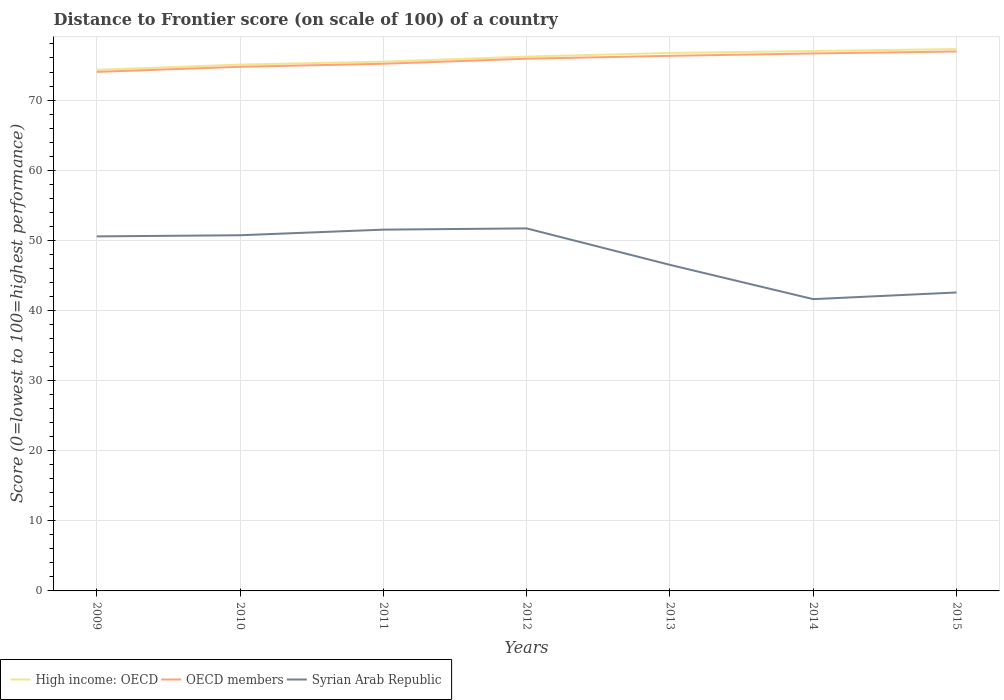Is the number of lines equal to the number of legend labels?
Provide a short and direct response. Yes. Across all years, what is the maximum distance to frontier score of in OECD members?
Make the answer very short. 74.02. What is the total distance to frontier score of in High income: OECD in the graph?
Provide a succinct answer. -1.66. What is the difference between the highest and the second highest distance to frontier score of in Syrian Arab Republic?
Provide a succinct answer. 10.09. What is the difference between the highest and the lowest distance to frontier score of in OECD members?
Your answer should be very brief. 4. What is the difference between two consecutive major ticks on the Y-axis?
Ensure brevity in your answer.  10. Are the values on the major ticks of Y-axis written in scientific E-notation?
Make the answer very short. No. Does the graph contain grids?
Ensure brevity in your answer.  Yes. Where does the legend appear in the graph?
Provide a succinct answer. Bottom left. How many legend labels are there?
Offer a very short reply. 3. What is the title of the graph?
Provide a short and direct response. Distance to Frontier score (on scale of 100) of a country. What is the label or title of the X-axis?
Provide a short and direct response. Years. What is the label or title of the Y-axis?
Provide a succinct answer. Score (0=lowest to 100=highest performance). What is the Score (0=lowest to 100=highest performance) in High income: OECD in 2009?
Keep it short and to the point. 74.31. What is the Score (0=lowest to 100=highest performance) of OECD members in 2009?
Your response must be concise. 74.02. What is the Score (0=lowest to 100=highest performance) in Syrian Arab Republic in 2009?
Offer a terse response. 50.56. What is the Score (0=lowest to 100=highest performance) in High income: OECD in 2010?
Give a very brief answer. 75.06. What is the Score (0=lowest to 100=highest performance) in OECD members in 2010?
Offer a terse response. 74.74. What is the Score (0=lowest to 100=highest performance) of Syrian Arab Republic in 2010?
Keep it short and to the point. 50.72. What is the Score (0=lowest to 100=highest performance) in High income: OECD in 2011?
Keep it short and to the point. 75.48. What is the Score (0=lowest to 100=highest performance) of OECD members in 2011?
Ensure brevity in your answer.  75.18. What is the Score (0=lowest to 100=highest performance) of Syrian Arab Republic in 2011?
Provide a succinct answer. 51.52. What is the Score (0=lowest to 100=highest performance) in High income: OECD in 2012?
Ensure brevity in your answer.  76.2. What is the Score (0=lowest to 100=highest performance) of OECD members in 2012?
Offer a very short reply. 75.9. What is the Score (0=lowest to 100=highest performance) of Syrian Arab Republic in 2012?
Ensure brevity in your answer.  51.7. What is the Score (0=lowest to 100=highest performance) in High income: OECD in 2013?
Ensure brevity in your answer.  76.72. What is the Score (0=lowest to 100=highest performance) in OECD members in 2013?
Ensure brevity in your answer.  76.31. What is the Score (0=lowest to 100=highest performance) in Syrian Arab Republic in 2013?
Your answer should be very brief. 46.5. What is the Score (0=lowest to 100=highest performance) of High income: OECD in 2014?
Your answer should be compact. 77. What is the Score (0=lowest to 100=highest performance) in OECD members in 2014?
Offer a very short reply. 76.65. What is the Score (0=lowest to 100=highest performance) of Syrian Arab Republic in 2014?
Provide a short and direct response. 41.61. What is the Score (0=lowest to 100=highest performance) of High income: OECD in 2015?
Offer a terse response. 77.27. What is the Score (0=lowest to 100=highest performance) in OECD members in 2015?
Give a very brief answer. 76.93. What is the Score (0=lowest to 100=highest performance) in Syrian Arab Republic in 2015?
Make the answer very short. 42.56. Across all years, what is the maximum Score (0=lowest to 100=highest performance) in High income: OECD?
Offer a very short reply. 77.27. Across all years, what is the maximum Score (0=lowest to 100=highest performance) of OECD members?
Offer a terse response. 76.93. Across all years, what is the maximum Score (0=lowest to 100=highest performance) of Syrian Arab Republic?
Your response must be concise. 51.7. Across all years, what is the minimum Score (0=lowest to 100=highest performance) of High income: OECD?
Offer a terse response. 74.31. Across all years, what is the minimum Score (0=lowest to 100=highest performance) in OECD members?
Your answer should be very brief. 74.02. Across all years, what is the minimum Score (0=lowest to 100=highest performance) of Syrian Arab Republic?
Your answer should be very brief. 41.61. What is the total Score (0=lowest to 100=highest performance) of High income: OECD in the graph?
Provide a succinct answer. 532.03. What is the total Score (0=lowest to 100=highest performance) in OECD members in the graph?
Offer a very short reply. 529.71. What is the total Score (0=lowest to 100=highest performance) in Syrian Arab Republic in the graph?
Your answer should be compact. 335.17. What is the difference between the Score (0=lowest to 100=highest performance) in High income: OECD in 2009 and that in 2010?
Keep it short and to the point. -0.75. What is the difference between the Score (0=lowest to 100=highest performance) in OECD members in 2009 and that in 2010?
Give a very brief answer. -0.73. What is the difference between the Score (0=lowest to 100=highest performance) in Syrian Arab Republic in 2009 and that in 2010?
Make the answer very short. -0.16. What is the difference between the Score (0=lowest to 100=highest performance) in High income: OECD in 2009 and that in 2011?
Your response must be concise. -1.17. What is the difference between the Score (0=lowest to 100=highest performance) in OECD members in 2009 and that in 2011?
Your answer should be compact. -1.16. What is the difference between the Score (0=lowest to 100=highest performance) of Syrian Arab Republic in 2009 and that in 2011?
Offer a terse response. -0.96. What is the difference between the Score (0=lowest to 100=highest performance) in High income: OECD in 2009 and that in 2012?
Ensure brevity in your answer.  -1.89. What is the difference between the Score (0=lowest to 100=highest performance) of OECD members in 2009 and that in 2012?
Keep it short and to the point. -1.88. What is the difference between the Score (0=lowest to 100=highest performance) in Syrian Arab Republic in 2009 and that in 2012?
Provide a succinct answer. -1.14. What is the difference between the Score (0=lowest to 100=highest performance) of High income: OECD in 2009 and that in 2013?
Make the answer very short. -2.41. What is the difference between the Score (0=lowest to 100=highest performance) in OECD members in 2009 and that in 2013?
Your answer should be compact. -2.29. What is the difference between the Score (0=lowest to 100=highest performance) in Syrian Arab Republic in 2009 and that in 2013?
Your answer should be compact. 4.06. What is the difference between the Score (0=lowest to 100=highest performance) of High income: OECD in 2009 and that in 2014?
Your answer should be very brief. -2.69. What is the difference between the Score (0=lowest to 100=highest performance) in OECD members in 2009 and that in 2014?
Your response must be concise. -2.63. What is the difference between the Score (0=lowest to 100=highest performance) in Syrian Arab Republic in 2009 and that in 2014?
Your answer should be compact. 8.95. What is the difference between the Score (0=lowest to 100=highest performance) of High income: OECD in 2009 and that in 2015?
Provide a short and direct response. -2.96. What is the difference between the Score (0=lowest to 100=highest performance) of OECD members in 2009 and that in 2015?
Offer a very short reply. -2.91. What is the difference between the Score (0=lowest to 100=highest performance) of Syrian Arab Republic in 2009 and that in 2015?
Ensure brevity in your answer.  8. What is the difference between the Score (0=lowest to 100=highest performance) of High income: OECD in 2010 and that in 2011?
Provide a succinct answer. -0.42. What is the difference between the Score (0=lowest to 100=highest performance) of OECD members in 2010 and that in 2011?
Your response must be concise. -0.43. What is the difference between the Score (0=lowest to 100=highest performance) in High income: OECD in 2010 and that in 2012?
Keep it short and to the point. -1.14. What is the difference between the Score (0=lowest to 100=highest performance) of OECD members in 2010 and that in 2012?
Provide a short and direct response. -1.15. What is the difference between the Score (0=lowest to 100=highest performance) of Syrian Arab Republic in 2010 and that in 2012?
Your answer should be compact. -0.98. What is the difference between the Score (0=lowest to 100=highest performance) of High income: OECD in 2010 and that in 2013?
Ensure brevity in your answer.  -1.66. What is the difference between the Score (0=lowest to 100=highest performance) in OECD members in 2010 and that in 2013?
Make the answer very short. -1.56. What is the difference between the Score (0=lowest to 100=highest performance) of Syrian Arab Republic in 2010 and that in 2013?
Ensure brevity in your answer.  4.22. What is the difference between the Score (0=lowest to 100=highest performance) of High income: OECD in 2010 and that in 2014?
Give a very brief answer. -1.94. What is the difference between the Score (0=lowest to 100=highest performance) of OECD members in 2010 and that in 2014?
Your answer should be very brief. -1.9. What is the difference between the Score (0=lowest to 100=highest performance) of Syrian Arab Republic in 2010 and that in 2014?
Your answer should be very brief. 9.11. What is the difference between the Score (0=lowest to 100=highest performance) in High income: OECD in 2010 and that in 2015?
Offer a very short reply. -2.21. What is the difference between the Score (0=lowest to 100=highest performance) of OECD members in 2010 and that in 2015?
Ensure brevity in your answer.  -2.18. What is the difference between the Score (0=lowest to 100=highest performance) of Syrian Arab Republic in 2010 and that in 2015?
Make the answer very short. 8.16. What is the difference between the Score (0=lowest to 100=highest performance) of High income: OECD in 2011 and that in 2012?
Your response must be concise. -0.72. What is the difference between the Score (0=lowest to 100=highest performance) in OECD members in 2011 and that in 2012?
Offer a terse response. -0.72. What is the difference between the Score (0=lowest to 100=highest performance) in Syrian Arab Republic in 2011 and that in 2012?
Make the answer very short. -0.18. What is the difference between the Score (0=lowest to 100=highest performance) of High income: OECD in 2011 and that in 2013?
Provide a short and direct response. -1.24. What is the difference between the Score (0=lowest to 100=highest performance) in OECD members in 2011 and that in 2013?
Keep it short and to the point. -1.13. What is the difference between the Score (0=lowest to 100=highest performance) in Syrian Arab Republic in 2011 and that in 2013?
Your response must be concise. 5.02. What is the difference between the Score (0=lowest to 100=highest performance) in High income: OECD in 2011 and that in 2014?
Give a very brief answer. -1.52. What is the difference between the Score (0=lowest to 100=highest performance) in OECD members in 2011 and that in 2014?
Keep it short and to the point. -1.47. What is the difference between the Score (0=lowest to 100=highest performance) of Syrian Arab Republic in 2011 and that in 2014?
Offer a very short reply. 9.91. What is the difference between the Score (0=lowest to 100=highest performance) of High income: OECD in 2011 and that in 2015?
Your answer should be very brief. -1.79. What is the difference between the Score (0=lowest to 100=highest performance) of OECD members in 2011 and that in 2015?
Offer a terse response. -1.75. What is the difference between the Score (0=lowest to 100=highest performance) in Syrian Arab Republic in 2011 and that in 2015?
Provide a short and direct response. 8.96. What is the difference between the Score (0=lowest to 100=highest performance) of High income: OECD in 2012 and that in 2013?
Provide a short and direct response. -0.52. What is the difference between the Score (0=lowest to 100=highest performance) in OECD members in 2012 and that in 2013?
Keep it short and to the point. -0.41. What is the difference between the Score (0=lowest to 100=highest performance) of Syrian Arab Republic in 2012 and that in 2013?
Offer a very short reply. 5.2. What is the difference between the Score (0=lowest to 100=highest performance) of High income: OECD in 2012 and that in 2014?
Your response must be concise. -0.8. What is the difference between the Score (0=lowest to 100=highest performance) in OECD members in 2012 and that in 2014?
Offer a very short reply. -0.75. What is the difference between the Score (0=lowest to 100=highest performance) of Syrian Arab Republic in 2012 and that in 2014?
Ensure brevity in your answer.  10.09. What is the difference between the Score (0=lowest to 100=highest performance) in High income: OECD in 2012 and that in 2015?
Your response must be concise. -1.07. What is the difference between the Score (0=lowest to 100=highest performance) of OECD members in 2012 and that in 2015?
Provide a succinct answer. -1.03. What is the difference between the Score (0=lowest to 100=highest performance) of Syrian Arab Republic in 2012 and that in 2015?
Provide a short and direct response. 9.14. What is the difference between the Score (0=lowest to 100=highest performance) of High income: OECD in 2013 and that in 2014?
Your answer should be compact. -0.28. What is the difference between the Score (0=lowest to 100=highest performance) in OECD members in 2013 and that in 2014?
Ensure brevity in your answer.  -0.34. What is the difference between the Score (0=lowest to 100=highest performance) of Syrian Arab Republic in 2013 and that in 2014?
Provide a succinct answer. 4.89. What is the difference between the Score (0=lowest to 100=highest performance) in High income: OECD in 2013 and that in 2015?
Offer a very short reply. -0.55. What is the difference between the Score (0=lowest to 100=highest performance) in OECD members in 2013 and that in 2015?
Give a very brief answer. -0.62. What is the difference between the Score (0=lowest to 100=highest performance) of Syrian Arab Republic in 2013 and that in 2015?
Your answer should be very brief. 3.94. What is the difference between the Score (0=lowest to 100=highest performance) of High income: OECD in 2014 and that in 2015?
Offer a very short reply. -0.27. What is the difference between the Score (0=lowest to 100=highest performance) in OECD members in 2014 and that in 2015?
Give a very brief answer. -0.28. What is the difference between the Score (0=lowest to 100=highest performance) of Syrian Arab Republic in 2014 and that in 2015?
Keep it short and to the point. -0.95. What is the difference between the Score (0=lowest to 100=highest performance) in High income: OECD in 2009 and the Score (0=lowest to 100=highest performance) in OECD members in 2010?
Your response must be concise. -0.44. What is the difference between the Score (0=lowest to 100=highest performance) in High income: OECD in 2009 and the Score (0=lowest to 100=highest performance) in Syrian Arab Republic in 2010?
Provide a succinct answer. 23.59. What is the difference between the Score (0=lowest to 100=highest performance) in OECD members in 2009 and the Score (0=lowest to 100=highest performance) in Syrian Arab Republic in 2010?
Give a very brief answer. 23.3. What is the difference between the Score (0=lowest to 100=highest performance) of High income: OECD in 2009 and the Score (0=lowest to 100=highest performance) of OECD members in 2011?
Your answer should be compact. -0.87. What is the difference between the Score (0=lowest to 100=highest performance) in High income: OECD in 2009 and the Score (0=lowest to 100=highest performance) in Syrian Arab Republic in 2011?
Ensure brevity in your answer.  22.79. What is the difference between the Score (0=lowest to 100=highest performance) of OECD members in 2009 and the Score (0=lowest to 100=highest performance) of Syrian Arab Republic in 2011?
Offer a very short reply. 22.5. What is the difference between the Score (0=lowest to 100=highest performance) of High income: OECD in 2009 and the Score (0=lowest to 100=highest performance) of OECD members in 2012?
Your answer should be compact. -1.59. What is the difference between the Score (0=lowest to 100=highest performance) of High income: OECD in 2009 and the Score (0=lowest to 100=highest performance) of Syrian Arab Republic in 2012?
Your answer should be very brief. 22.61. What is the difference between the Score (0=lowest to 100=highest performance) of OECD members in 2009 and the Score (0=lowest to 100=highest performance) of Syrian Arab Republic in 2012?
Make the answer very short. 22.32. What is the difference between the Score (0=lowest to 100=highest performance) of High income: OECD in 2009 and the Score (0=lowest to 100=highest performance) of OECD members in 2013?
Ensure brevity in your answer.  -2. What is the difference between the Score (0=lowest to 100=highest performance) of High income: OECD in 2009 and the Score (0=lowest to 100=highest performance) of Syrian Arab Republic in 2013?
Offer a terse response. 27.81. What is the difference between the Score (0=lowest to 100=highest performance) of OECD members in 2009 and the Score (0=lowest to 100=highest performance) of Syrian Arab Republic in 2013?
Give a very brief answer. 27.52. What is the difference between the Score (0=lowest to 100=highest performance) of High income: OECD in 2009 and the Score (0=lowest to 100=highest performance) of OECD members in 2014?
Provide a short and direct response. -2.34. What is the difference between the Score (0=lowest to 100=highest performance) in High income: OECD in 2009 and the Score (0=lowest to 100=highest performance) in Syrian Arab Republic in 2014?
Your response must be concise. 32.7. What is the difference between the Score (0=lowest to 100=highest performance) in OECD members in 2009 and the Score (0=lowest to 100=highest performance) in Syrian Arab Republic in 2014?
Offer a very short reply. 32.41. What is the difference between the Score (0=lowest to 100=highest performance) of High income: OECD in 2009 and the Score (0=lowest to 100=highest performance) of OECD members in 2015?
Provide a short and direct response. -2.62. What is the difference between the Score (0=lowest to 100=highest performance) in High income: OECD in 2009 and the Score (0=lowest to 100=highest performance) in Syrian Arab Republic in 2015?
Your answer should be very brief. 31.75. What is the difference between the Score (0=lowest to 100=highest performance) of OECD members in 2009 and the Score (0=lowest to 100=highest performance) of Syrian Arab Republic in 2015?
Your response must be concise. 31.46. What is the difference between the Score (0=lowest to 100=highest performance) in High income: OECD in 2010 and the Score (0=lowest to 100=highest performance) in OECD members in 2011?
Make the answer very short. -0.12. What is the difference between the Score (0=lowest to 100=highest performance) in High income: OECD in 2010 and the Score (0=lowest to 100=highest performance) in Syrian Arab Republic in 2011?
Provide a short and direct response. 23.54. What is the difference between the Score (0=lowest to 100=highest performance) in OECD members in 2010 and the Score (0=lowest to 100=highest performance) in Syrian Arab Republic in 2011?
Your answer should be very brief. 23.22. What is the difference between the Score (0=lowest to 100=highest performance) in High income: OECD in 2010 and the Score (0=lowest to 100=highest performance) in OECD members in 2012?
Offer a terse response. -0.84. What is the difference between the Score (0=lowest to 100=highest performance) of High income: OECD in 2010 and the Score (0=lowest to 100=highest performance) of Syrian Arab Republic in 2012?
Provide a succinct answer. 23.36. What is the difference between the Score (0=lowest to 100=highest performance) of OECD members in 2010 and the Score (0=lowest to 100=highest performance) of Syrian Arab Republic in 2012?
Your answer should be very brief. 23.04. What is the difference between the Score (0=lowest to 100=highest performance) in High income: OECD in 2010 and the Score (0=lowest to 100=highest performance) in OECD members in 2013?
Offer a very short reply. -1.25. What is the difference between the Score (0=lowest to 100=highest performance) in High income: OECD in 2010 and the Score (0=lowest to 100=highest performance) in Syrian Arab Republic in 2013?
Make the answer very short. 28.56. What is the difference between the Score (0=lowest to 100=highest performance) in OECD members in 2010 and the Score (0=lowest to 100=highest performance) in Syrian Arab Republic in 2013?
Ensure brevity in your answer.  28.24. What is the difference between the Score (0=lowest to 100=highest performance) in High income: OECD in 2010 and the Score (0=lowest to 100=highest performance) in OECD members in 2014?
Provide a succinct answer. -1.59. What is the difference between the Score (0=lowest to 100=highest performance) in High income: OECD in 2010 and the Score (0=lowest to 100=highest performance) in Syrian Arab Republic in 2014?
Your answer should be compact. 33.45. What is the difference between the Score (0=lowest to 100=highest performance) in OECD members in 2010 and the Score (0=lowest to 100=highest performance) in Syrian Arab Republic in 2014?
Make the answer very short. 33.13. What is the difference between the Score (0=lowest to 100=highest performance) in High income: OECD in 2010 and the Score (0=lowest to 100=highest performance) in OECD members in 2015?
Ensure brevity in your answer.  -1.87. What is the difference between the Score (0=lowest to 100=highest performance) of High income: OECD in 2010 and the Score (0=lowest to 100=highest performance) of Syrian Arab Republic in 2015?
Make the answer very short. 32.5. What is the difference between the Score (0=lowest to 100=highest performance) in OECD members in 2010 and the Score (0=lowest to 100=highest performance) in Syrian Arab Republic in 2015?
Your answer should be very brief. 32.18. What is the difference between the Score (0=lowest to 100=highest performance) in High income: OECD in 2011 and the Score (0=lowest to 100=highest performance) in OECD members in 2012?
Make the answer very short. -0.42. What is the difference between the Score (0=lowest to 100=highest performance) of High income: OECD in 2011 and the Score (0=lowest to 100=highest performance) of Syrian Arab Republic in 2012?
Your response must be concise. 23.78. What is the difference between the Score (0=lowest to 100=highest performance) in OECD members in 2011 and the Score (0=lowest to 100=highest performance) in Syrian Arab Republic in 2012?
Ensure brevity in your answer.  23.48. What is the difference between the Score (0=lowest to 100=highest performance) in High income: OECD in 2011 and the Score (0=lowest to 100=highest performance) in OECD members in 2013?
Keep it short and to the point. -0.83. What is the difference between the Score (0=lowest to 100=highest performance) of High income: OECD in 2011 and the Score (0=lowest to 100=highest performance) of Syrian Arab Republic in 2013?
Make the answer very short. 28.98. What is the difference between the Score (0=lowest to 100=highest performance) of OECD members in 2011 and the Score (0=lowest to 100=highest performance) of Syrian Arab Republic in 2013?
Give a very brief answer. 28.68. What is the difference between the Score (0=lowest to 100=highest performance) of High income: OECD in 2011 and the Score (0=lowest to 100=highest performance) of OECD members in 2014?
Provide a short and direct response. -1.17. What is the difference between the Score (0=lowest to 100=highest performance) of High income: OECD in 2011 and the Score (0=lowest to 100=highest performance) of Syrian Arab Republic in 2014?
Your answer should be compact. 33.87. What is the difference between the Score (0=lowest to 100=highest performance) in OECD members in 2011 and the Score (0=lowest to 100=highest performance) in Syrian Arab Republic in 2014?
Keep it short and to the point. 33.57. What is the difference between the Score (0=lowest to 100=highest performance) in High income: OECD in 2011 and the Score (0=lowest to 100=highest performance) in OECD members in 2015?
Provide a short and direct response. -1.45. What is the difference between the Score (0=lowest to 100=highest performance) of High income: OECD in 2011 and the Score (0=lowest to 100=highest performance) of Syrian Arab Republic in 2015?
Keep it short and to the point. 32.92. What is the difference between the Score (0=lowest to 100=highest performance) of OECD members in 2011 and the Score (0=lowest to 100=highest performance) of Syrian Arab Republic in 2015?
Keep it short and to the point. 32.62. What is the difference between the Score (0=lowest to 100=highest performance) of High income: OECD in 2012 and the Score (0=lowest to 100=highest performance) of OECD members in 2013?
Ensure brevity in your answer.  -0.11. What is the difference between the Score (0=lowest to 100=highest performance) of High income: OECD in 2012 and the Score (0=lowest to 100=highest performance) of Syrian Arab Republic in 2013?
Keep it short and to the point. 29.7. What is the difference between the Score (0=lowest to 100=highest performance) in OECD members in 2012 and the Score (0=lowest to 100=highest performance) in Syrian Arab Republic in 2013?
Your response must be concise. 29.4. What is the difference between the Score (0=lowest to 100=highest performance) in High income: OECD in 2012 and the Score (0=lowest to 100=highest performance) in OECD members in 2014?
Offer a terse response. -0.45. What is the difference between the Score (0=lowest to 100=highest performance) in High income: OECD in 2012 and the Score (0=lowest to 100=highest performance) in Syrian Arab Republic in 2014?
Make the answer very short. 34.59. What is the difference between the Score (0=lowest to 100=highest performance) of OECD members in 2012 and the Score (0=lowest to 100=highest performance) of Syrian Arab Republic in 2014?
Offer a very short reply. 34.29. What is the difference between the Score (0=lowest to 100=highest performance) of High income: OECD in 2012 and the Score (0=lowest to 100=highest performance) of OECD members in 2015?
Provide a succinct answer. -0.73. What is the difference between the Score (0=lowest to 100=highest performance) in High income: OECD in 2012 and the Score (0=lowest to 100=highest performance) in Syrian Arab Republic in 2015?
Offer a very short reply. 33.64. What is the difference between the Score (0=lowest to 100=highest performance) of OECD members in 2012 and the Score (0=lowest to 100=highest performance) of Syrian Arab Republic in 2015?
Your answer should be very brief. 33.34. What is the difference between the Score (0=lowest to 100=highest performance) in High income: OECD in 2013 and the Score (0=lowest to 100=highest performance) in OECD members in 2014?
Ensure brevity in your answer.  0.07. What is the difference between the Score (0=lowest to 100=highest performance) in High income: OECD in 2013 and the Score (0=lowest to 100=highest performance) in Syrian Arab Republic in 2014?
Offer a terse response. 35.11. What is the difference between the Score (0=lowest to 100=highest performance) of OECD members in 2013 and the Score (0=lowest to 100=highest performance) of Syrian Arab Republic in 2014?
Your answer should be compact. 34.7. What is the difference between the Score (0=lowest to 100=highest performance) of High income: OECD in 2013 and the Score (0=lowest to 100=highest performance) of OECD members in 2015?
Provide a short and direct response. -0.21. What is the difference between the Score (0=lowest to 100=highest performance) in High income: OECD in 2013 and the Score (0=lowest to 100=highest performance) in Syrian Arab Republic in 2015?
Make the answer very short. 34.16. What is the difference between the Score (0=lowest to 100=highest performance) of OECD members in 2013 and the Score (0=lowest to 100=highest performance) of Syrian Arab Republic in 2015?
Provide a short and direct response. 33.75. What is the difference between the Score (0=lowest to 100=highest performance) of High income: OECD in 2014 and the Score (0=lowest to 100=highest performance) of OECD members in 2015?
Keep it short and to the point. 0.07. What is the difference between the Score (0=lowest to 100=highest performance) in High income: OECD in 2014 and the Score (0=lowest to 100=highest performance) in Syrian Arab Republic in 2015?
Provide a succinct answer. 34.44. What is the difference between the Score (0=lowest to 100=highest performance) in OECD members in 2014 and the Score (0=lowest to 100=highest performance) in Syrian Arab Republic in 2015?
Your answer should be very brief. 34.09. What is the average Score (0=lowest to 100=highest performance) in High income: OECD per year?
Offer a terse response. 76. What is the average Score (0=lowest to 100=highest performance) in OECD members per year?
Keep it short and to the point. 75.67. What is the average Score (0=lowest to 100=highest performance) in Syrian Arab Republic per year?
Give a very brief answer. 47.88. In the year 2009, what is the difference between the Score (0=lowest to 100=highest performance) in High income: OECD and Score (0=lowest to 100=highest performance) in OECD members?
Your answer should be compact. 0.29. In the year 2009, what is the difference between the Score (0=lowest to 100=highest performance) in High income: OECD and Score (0=lowest to 100=highest performance) in Syrian Arab Republic?
Your answer should be compact. 23.75. In the year 2009, what is the difference between the Score (0=lowest to 100=highest performance) in OECD members and Score (0=lowest to 100=highest performance) in Syrian Arab Republic?
Your response must be concise. 23.46. In the year 2010, what is the difference between the Score (0=lowest to 100=highest performance) in High income: OECD and Score (0=lowest to 100=highest performance) in OECD members?
Give a very brief answer. 0.31. In the year 2010, what is the difference between the Score (0=lowest to 100=highest performance) in High income: OECD and Score (0=lowest to 100=highest performance) in Syrian Arab Republic?
Give a very brief answer. 24.34. In the year 2010, what is the difference between the Score (0=lowest to 100=highest performance) in OECD members and Score (0=lowest to 100=highest performance) in Syrian Arab Republic?
Your answer should be very brief. 24.02. In the year 2011, what is the difference between the Score (0=lowest to 100=highest performance) of High income: OECD and Score (0=lowest to 100=highest performance) of OECD members?
Ensure brevity in your answer.  0.3. In the year 2011, what is the difference between the Score (0=lowest to 100=highest performance) in High income: OECD and Score (0=lowest to 100=highest performance) in Syrian Arab Republic?
Your answer should be very brief. 23.96. In the year 2011, what is the difference between the Score (0=lowest to 100=highest performance) of OECD members and Score (0=lowest to 100=highest performance) of Syrian Arab Republic?
Provide a short and direct response. 23.66. In the year 2012, what is the difference between the Score (0=lowest to 100=highest performance) in High income: OECD and Score (0=lowest to 100=highest performance) in OECD members?
Offer a terse response. 0.3. In the year 2012, what is the difference between the Score (0=lowest to 100=highest performance) of High income: OECD and Score (0=lowest to 100=highest performance) of Syrian Arab Republic?
Keep it short and to the point. 24.5. In the year 2012, what is the difference between the Score (0=lowest to 100=highest performance) in OECD members and Score (0=lowest to 100=highest performance) in Syrian Arab Republic?
Ensure brevity in your answer.  24.2. In the year 2013, what is the difference between the Score (0=lowest to 100=highest performance) in High income: OECD and Score (0=lowest to 100=highest performance) in OECD members?
Offer a terse response. 0.41. In the year 2013, what is the difference between the Score (0=lowest to 100=highest performance) of High income: OECD and Score (0=lowest to 100=highest performance) of Syrian Arab Republic?
Provide a short and direct response. 30.22. In the year 2013, what is the difference between the Score (0=lowest to 100=highest performance) in OECD members and Score (0=lowest to 100=highest performance) in Syrian Arab Republic?
Make the answer very short. 29.81. In the year 2014, what is the difference between the Score (0=lowest to 100=highest performance) in High income: OECD and Score (0=lowest to 100=highest performance) in OECD members?
Ensure brevity in your answer.  0.35. In the year 2014, what is the difference between the Score (0=lowest to 100=highest performance) in High income: OECD and Score (0=lowest to 100=highest performance) in Syrian Arab Republic?
Offer a terse response. 35.39. In the year 2014, what is the difference between the Score (0=lowest to 100=highest performance) in OECD members and Score (0=lowest to 100=highest performance) in Syrian Arab Republic?
Give a very brief answer. 35.04. In the year 2015, what is the difference between the Score (0=lowest to 100=highest performance) in High income: OECD and Score (0=lowest to 100=highest performance) in OECD members?
Offer a very short reply. 0.34. In the year 2015, what is the difference between the Score (0=lowest to 100=highest performance) in High income: OECD and Score (0=lowest to 100=highest performance) in Syrian Arab Republic?
Offer a very short reply. 34.71. In the year 2015, what is the difference between the Score (0=lowest to 100=highest performance) of OECD members and Score (0=lowest to 100=highest performance) of Syrian Arab Republic?
Keep it short and to the point. 34.37. What is the ratio of the Score (0=lowest to 100=highest performance) of OECD members in 2009 to that in 2010?
Your answer should be compact. 0.99. What is the ratio of the Score (0=lowest to 100=highest performance) of High income: OECD in 2009 to that in 2011?
Give a very brief answer. 0.98. What is the ratio of the Score (0=lowest to 100=highest performance) of OECD members in 2009 to that in 2011?
Offer a very short reply. 0.98. What is the ratio of the Score (0=lowest to 100=highest performance) in Syrian Arab Republic in 2009 to that in 2011?
Your answer should be compact. 0.98. What is the ratio of the Score (0=lowest to 100=highest performance) in High income: OECD in 2009 to that in 2012?
Provide a succinct answer. 0.98. What is the ratio of the Score (0=lowest to 100=highest performance) in OECD members in 2009 to that in 2012?
Your answer should be very brief. 0.98. What is the ratio of the Score (0=lowest to 100=highest performance) of Syrian Arab Republic in 2009 to that in 2012?
Keep it short and to the point. 0.98. What is the ratio of the Score (0=lowest to 100=highest performance) of High income: OECD in 2009 to that in 2013?
Your response must be concise. 0.97. What is the ratio of the Score (0=lowest to 100=highest performance) of Syrian Arab Republic in 2009 to that in 2013?
Provide a succinct answer. 1.09. What is the ratio of the Score (0=lowest to 100=highest performance) of High income: OECD in 2009 to that in 2014?
Offer a terse response. 0.97. What is the ratio of the Score (0=lowest to 100=highest performance) in OECD members in 2009 to that in 2014?
Your response must be concise. 0.97. What is the ratio of the Score (0=lowest to 100=highest performance) in Syrian Arab Republic in 2009 to that in 2014?
Provide a succinct answer. 1.22. What is the ratio of the Score (0=lowest to 100=highest performance) in High income: OECD in 2009 to that in 2015?
Provide a succinct answer. 0.96. What is the ratio of the Score (0=lowest to 100=highest performance) of OECD members in 2009 to that in 2015?
Keep it short and to the point. 0.96. What is the ratio of the Score (0=lowest to 100=highest performance) in Syrian Arab Republic in 2009 to that in 2015?
Provide a short and direct response. 1.19. What is the ratio of the Score (0=lowest to 100=highest performance) in High income: OECD in 2010 to that in 2011?
Offer a terse response. 0.99. What is the ratio of the Score (0=lowest to 100=highest performance) of Syrian Arab Republic in 2010 to that in 2011?
Make the answer very short. 0.98. What is the ratio of the Score (0=lowest to 100=highest performance) of High income: OECD in 2010 to that in 2012?
Make the answer very short. 0.99. What is the ratio of the Score (0=lowest to 100=highest performance) of Syrian Arab Republic in 2010 to that in 2012?
Offer a terse response. 0.98. What is the ratio of the Score (0=lowest to 100=highest performance) in High income: OECD in 2010 to that in 2013?
Your answer should be compact. 0.98. What is the ratio of the Score (0=lowest to 100=highest performance) in OECD members in 2010 to that in 2013?
Your answer should be compact. 0.98. What is the ratio of the Score (0=lowest to 100=highest performance) in Syrian Arab Republic in 2010 to that in 2013?
Give a very brief answer. 1.09. What is the ratio of the Score (0=lowest to 100=highest performance) in High income: OECD in 2010 to that in 2014?
Make the answer very short. 0.97. What is the ratio of the Score (0=lowest to 100=highest performance) of OECD members in 2010 to that in 2014?
Ensure brevity in your answer.  0.98. What is the ratio of the Score (0=lowest to 100=highest performance) of Syrian Arab Republic in 2010 to that in 2014?
Offer a very short reply. 1.22. What is the ratio of the Score (0=lowest to 100=highest performance) of High income: OECD in 2010 to that in 2015?
Offer a terse response. 0.97. What is the ratio of the Score (0=lowest to 100=highest performance) of OECD members in 2010 to that in 2015?
Offer a very short reply. 0.97. What is the ratio of the Score (0=lowest to 100=highest performance) of Syrian Arab Republic in 2010 to that in 2015?
Provide a short and direct response. 1.19. What is the ratio of the Score (0=lowest to 100=highest performance) of High income: OECD in 2011 to that in 2012?
Give a very brief answer. 0.99. What is the ratio of the Score (0=lowest to 100=highest performance) in Syrian Arab Republic in 2011 to that in 2012?
Your response must be concise. 1. What is the ratio of the Score (0=lowest to 100=highest performance) in High income: OECD in 2011 to that in 2013?
Your answer should be compact. 0.98. What is the ratio of the Score (0=lowest to 100=highest performance) in OECD members in 2011 to that in 2013?
Your answer should be very brief. 0.99. What is the ratio of the Score (0=lowest to 100=highest performance) in Syrian Arab Republic in 2011 to that in 2013?
Provide a short and direct response. 1.11. What is the ratio of the Score (0=lowest to 100=highest performance) in High income: OECD in 2011 to that in 2014?
Provide a succinct answer. 0.98. What is the ratio of the Score (0=lowest to 100=highest performance) in OECD members in 2011 to that in 2014?
Your response must be concise. 0.98. What is the ratio of the Score (0=lowest to 100=highest performance) of Syrian Arab Republic in 2011 to that in 2014?
Provide a succinct answer. 1.24. What is the ratio of the Score (0=lowest to 100=highest performance) of High income: OECD in 2011 to that in 2015?
Your answer should be very brief. 0.98. What is the ratio of the Score (0=lowest to 100=highest performance) of OECD members in 2011 to that in 2015?
Your response must be concise. 0.98. What is the ratio of the Score (0=lowest to 100=highest performance) of Syrian Arab Republic in 2011 to that in 2015?
Give a very brief answer. 1.21. What is the ratio of the Score (0=lowest to 100=highest performance) of OECD members in 2012 to that in 2013?
Your response must be concise. 0.99. What is the ratio of the Score (0=lowest to 100=highest performance) in Syrian Arab Republic in 2012 to that in 2013?
Make the answer very short. 1.11. What is the ratio of the Score (0=lowest to 100=highest performance) in OECD members in 2012 to that in 2014?
Offer a terse response. 0.99. What is the ratio of the Score (0=lowest to 100=highest performance) in Syrian Arab Republic in 2012 to that in 2014?
Your answer should be compact. 1.24. What is the ratio of the Score (0=lowest to 100=highest performance) of High income: OECD in 2012 to that in 2015?
Give a very brief answer. 0.99. What is the ratio of the Score (0=lowest to 100=highest performance) in OECD members in 2012 to that in 2015?
Keep it short and to the point. 0.99. What is the ratio of the Score (0=lowest to 100=highest performance) of Syrian Arab Republic in 2012 to that in 2015?
Provide a short and direct response. 1.21. What is the ratio of the Score (0=lowest to 100=highest performance) in Syrian Arab Republic in 2013 to that in 2014?
Give a very brief answer. 1.12. What is the ratio of the Score (0=lowest to 100=highest performance) in OECD members in 2013 to that in 2015?
Offer a terse response. 0.99. What is the ratio of the Score (0=lowest to 100=highest performance) in Syrian Arab Republic in 2013 to that in 2015?
Offer a terse response. 1.09. What is the ratio of the Score (0=lowest to 100=highest performance) of High income: OECD in 2014 to that in 2015?
Provide a short and direct response. 1. What is the ratio of the Score (0=lowest to 100=highest performance) in OECD members in 2014 to that in 2015?
Provide a short and direct response. 1. What is the ratio of the Score (0=lowest to 100=highest performance) in Syrian Arab Republic in 2014 to that in 2015?
Provide a short and direct response. 0.98. What is the difference between the highest and the second highest Score (0=lowest to 100=highest performance) of High income: OECD?
Make the answer very short. 0.27. What is the difference between the highest and the second highest Score (0=lowest to 100=highest performance) of OECD members?
Give a very brief answer. 0.28. What is the difference between the highest and the second highest Score (0=lowest to 100=highest performance) of Syrian Arab Republic?
Make the answer very short. 0.18. What is the difference between the highest and the lowest Score (0=lowest to 100=highest performance) in High income: OECD?
Provide a short and direct response. 2.96. What is the difference between the highest and the lowest Score (0=lowest to 100=highest performance) in OECD members?
Give a very brief answer. 2.91. What is the difference between the highest and the lowest Score (0=lowest to 100=highest performance) of Syrian Arab Republic?
Give a very brief answer. 10.09. 